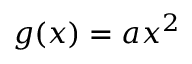<formula> <loc_0><loc_0><loc_500><loc_500>g ( x ) = a x ^ { 2 } \,</formula> 